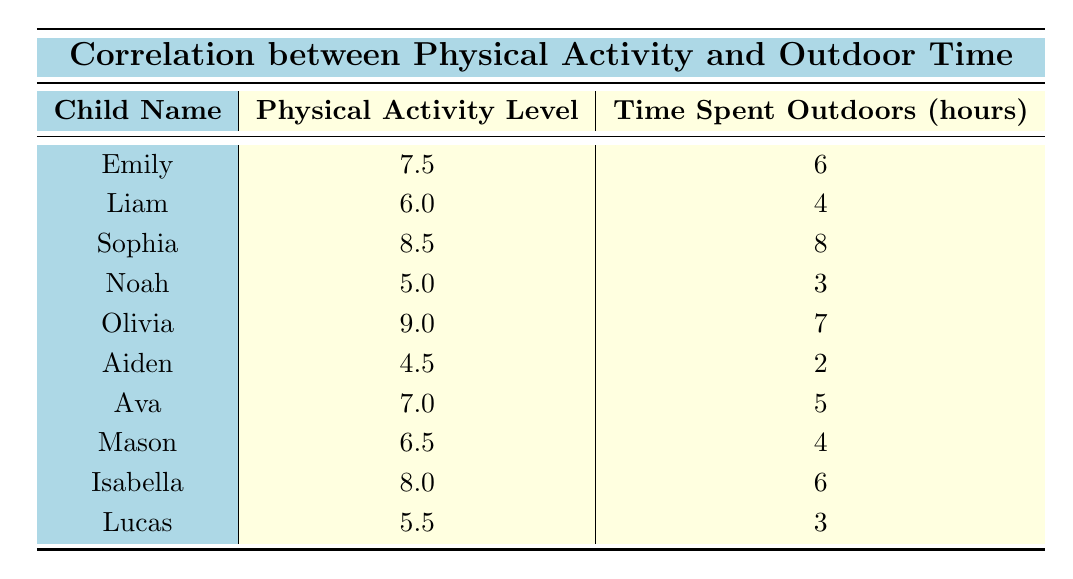What is the physical activity level of Olivia? According to the table, Olivia's row shows that her physical activity level is 9.0.
Answer: 9.0 Which child spent the most time outdoors? By comparing the "Time Spent Outdoors" column in the table, Sophia has the highest value at 8 hours.
Answer: Sophia What is the average physical activity level of the children listed? To find the average, sum all physical activity levels: (7.5 + 6.0 + 8.5 + 5.0 + 9.0 + 4.5 + 7.0 + 6.5 + 8.0 + 5.5) = 58.5. There are 10 children, so the average is 58.5 / 10 = 5.85.
Answer: 5.85 Is there a child with a physical activity level below 5? Aiden has a physical activity level of 4.5, which is below 5. Thus, the answer is yes.
Answer: Yes What is the total time spent outdoors by all children? Adding the hours spent outdoors from all children gives: (6 + 4 + 8 + 3 + 7 + 2 + 5 + 4 + 6 + 3) = 48 hours.
Answer: 48 How many children have physical activity levels above 6? The children with physical activity levels above 6 are Emily (7.5), Sophia (8.5), Olivia (9.0), Ava (7.0), and Isabella (8.0). Counting these, there are 5 children.
Answer: 5 What is the difference in physical activity levels between the child with the highest and lowest levels? The highest physical activity level is Olivia with 9.0 and the lowest is Aiden with 4.5. The difference is 9.0 - 4.5 = 4.5.
Answer: 4.5 Is there any child whose physical activity level matches the time spent outdoors? Examining the table, no child has the same value for physical activity level and time spent outdoors, so the answer is no.
Answer: No 